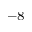Convert formula to latex. <formula><loc_0><loc_0><loc_500><loc_500>^ { - 8 }</formula> 